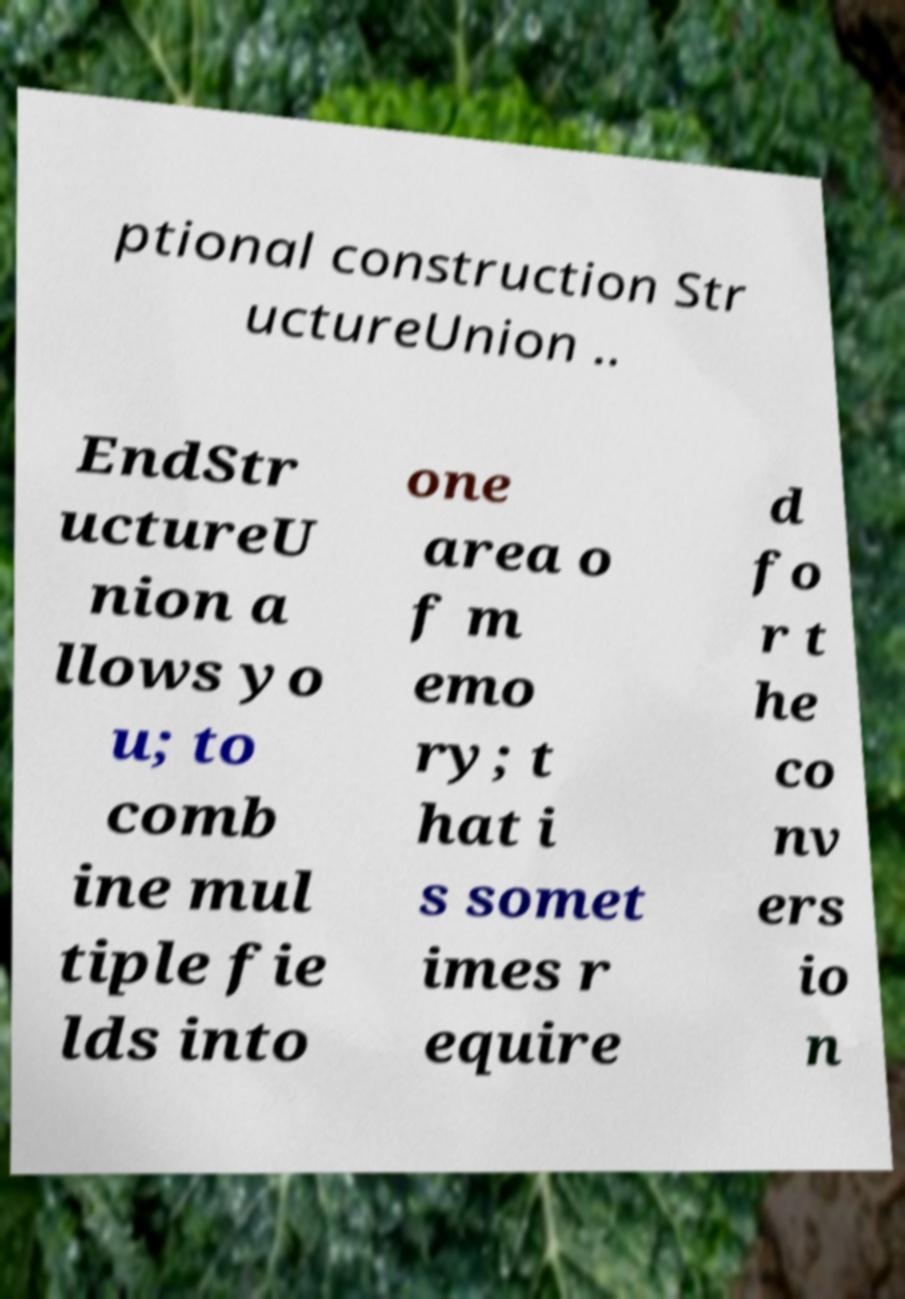Can you accurately transcribe the text from the provided image for me? ptional construction Str uctureUnion .. EndStr uctureU nion a llows yo u; to comb ine mul tiple fie lds into one area o f m emo ry; t hat i s somet imes r equire d fo r t he co nv ers io n 